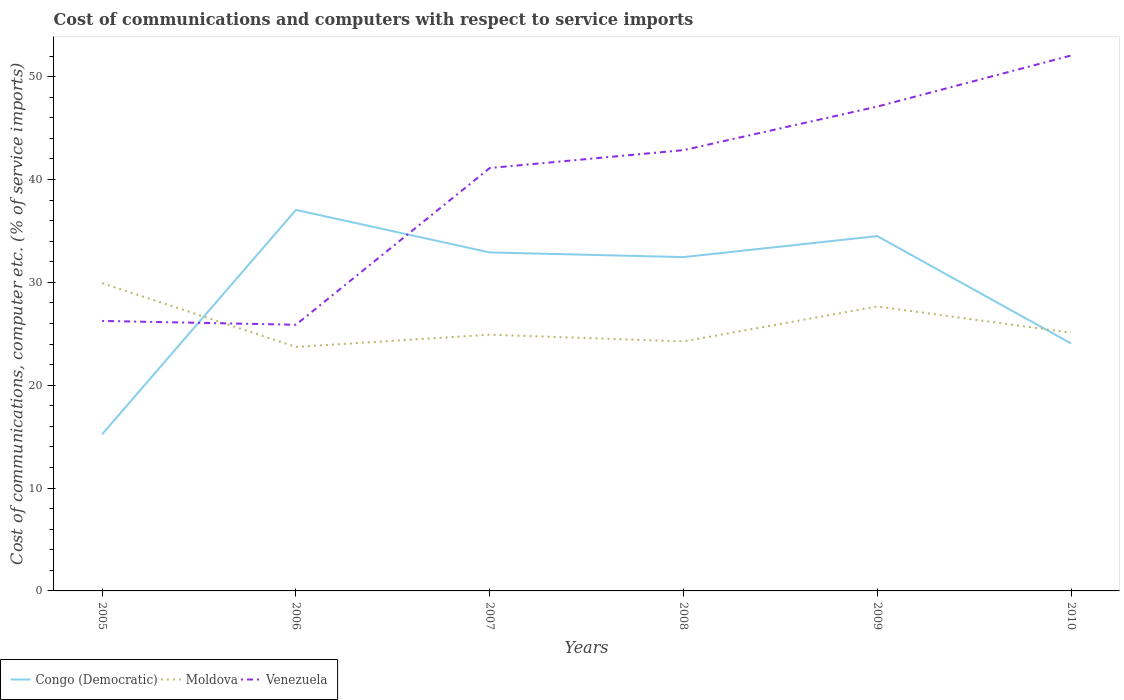Is the number of lines equal to the number of legend labels?
Your answer should be very brief. Yes. Across all years, what is the maximum cost of communications and computers in Moldova?
Make the answer very short. 23.72. What is the total cost of communications and computers in Congo (Democratic) in the graph?
Make the answer very short. 8.4. What is the difference between the highest and the second highest cost of communications and computers in Venezuela?
Offer a terse response. 26.18. What is the difference between the highest and the lowest cost of communications and computers in Congo (Democratic)?
Ensure brevity in your answer.  4. Is the cost of communications and computers in Moldova strictly greater than the cost of communications and computers in Congo (Democratic) over the years?
Make the answer very short. No. How many lines are there?
Your answer should be compact. 3. Are the values on the major ticks of Y-axis written in scientific E-notation?
Provide a succinct answer. No. What is the title of the graph?
Offer a terse response. Cost of communications and computers with respect to service imports. Does "Belize" appear as one of the legend labels in the graph?
Your answer should be very brief. No. What is the label or title of the X-axis?
Provide a short and direct response. Years. What is the label or title of the Y-axis?
Offer a very short reply. Cost of communications, computer etc. (% of service imports). What is the Cost of communications, computer etc. (% of service imports) of Congo (Democratic) in 2005?
Offer a terse response. 15.23. What is the Cost of communications, computer etc. (% of service imports) of Moldova in 2005?
Give a very brief answer. 29.92. What is the Cost of communications, computer etc. (% of service imports) in Venezuela in 2005?
Offer a terse response. 26.25. What is the Cost of communications, computer etc. (% of service imports) in Congo (Democratic) in 2006?
Provide a short and direct response. 37.04. What is the Cost of communications, computer etc. (% of service imports) in Moldova in 2006?
Keep it short and to the point. 23.72. What is the Cost of communications, computer etc. (% of service imports) in Venezuela in 2006?
Your answer should be very brief. 25.88. What is the Cost of communications, computer etc. (% of service imports) of Congo (Democratic) in 2007?
Your answer should be compact. 32.91. What is the Cost of communications, computer etc. (% of service imports) in Moldova in 2007?
Offer a terse response. 24.91. What is the Cost of communications, computer etc. (% of service imports) in Venezuela in 2007?
Your answer should be compact. 41.11. What is the Cost of communications, computer etc. (% of service imports) in Congo (Democratic) in 2008?
Keep it short and to the point. 32.45. What is the Cost of communications, computer etc. (% of service imports) of Moldova in 2008?
Provide a short and direct response. 24.26. What is the Cost of communications, computer etc. (% of service imports) in Venezuela in 2008?
Make the answer very short. 42.85. What is the Cost of communications, computer etc. (% of service imports) in Congo (Democratic) in 2009?
Provide a short and direct response. 34.49. What is the Cost of communications, computer etc. (% of service imports) in Moldova in 2009?
Ensure brevity in your answer.  27.65. What is the Cost of communications, computer etc. (% of service imports) of Venezuela in 2009?
Offer a very short reply. 47.09. What is the Cost of communications, computer etc. (% of service imports) in Congo (Democratic) in 2010?
Offer a terse response. 24.06. What is the Cost of communications, computer etc. (% of service imports) in Moldova in 2010?
Provide a succinct answer. 25.1. What is the Cost of communications, computer etc. (% of service imports) of Venezuela in 2010?
Your response must be concise. 52.05. Across all years, what is the maximum Cost of communications, computer etc. (% of service imports) of Congo (Democratic)?
Ensure brevity in your answer.  37.04. Across all years, what is the maximum Cost of communications, computer etc. (% of service imports) in Moldova?
Give a very brief answer. 29.92. Across all years, what is the maximum Cost of communications, computer etc. (% of service imports) of Venezuela?
Provide a succinct answer. 52.05. Across all years, what is the minimum Cost of communications, computer etc. (% of service imports) of Congo (Democratic)?
Make the answer very short. 15.23. Across all years, what is the minimum Cost of communications, computer etc. (% of service imports) of Moldova?
Give a very brief answer. 23.72. Across all years, what is the minimum Cost of communications, computer etc. (% of service imports) of Venezuela?
Make the answer very short. 25.88. What is the total Cost of communications, computer etc. (% of service imports) of Congo (Democratic) in the graph?
Offer a terse response. 176.19. What is the total Cost of communications, computer etc. (% of service imports) of Moldova in the graph?
Give a very brief answer. 155.56. What is the total Cost of communications, computer etc. (% of service imports) of Venezuela in the graph?
Offer a very short reply. 235.23. What is the difference between the Cost of communications, computer etc. (% of service imports) of Congo (Democratic) in 2005 and that in 2006?
Your response must be concise. -21.81. What is the difference between the Cost of communications, computer etc. (% of service imports) in Moldova in 2005 and that in 2006?
Keep it short and to the point. 6.2. What is the difference between the Cost of communications, computer etc. (% of service imports) in Venezuela in 2005 and that in 2006?
Provide a succinct answer. 0.37. What is the difference between the Cost of communications, computer etc. (% of service imports) in Congo (Democratic) in 2005 and that in 2007?
Your answer should be very brief. -17.67. What is the difference between the Cost of communications, computer etc. (% of service imports) in Moldova in 2005 and that in 2007?
Your response must be concise. 5.01. What is the difference between the Cost of communications, computer etc. (% of service imports) in Venezuela in 2005 and that in 2007?
Offer a very short reply. -14.86. What is the difference between the Cost of communications, computer etc. (% of service imports) in Congo (Democratic) in 2005 and that in 2008?
Keep it short and to the point. -17.22. What is the difference between the Cost of communications, computer etc. (% of service imports) of Moldova in 2005 and that in 2008?
Provide a short and direct response. 5.66. What is the difference between the Cost of communications, computer etc. (% of service imports) of Venezuela in 2005 and that in 2008?
Your answer should be very brief. -16.6. What is the difference between the Cost of communications, computer etc. (% of service imports) of Congo (Democratic) in 2005 and that in 2009?
Provide a succinct answer. -19.26. What is the difference between the Cost of communications, computer etc. (% of service imports) of Moldova in 2005 and that in 2009?
Your response must be concise. 2.27. What is the difference between the Cost of communications, computer etc. (% of service imports) of Venezuela in 2005 and that in 2009?
Provide a succinct answer. -20.84. What is the difference between the Cost of communications, computer etc. (% of service imports) of Congo (Democratic) in 2005 and that in 2010?
Ensure brevity in your answer.  -8.83. What is the difference between the Cost of communications, computer etc. (% of service imports) of Moldova in 2005 and that in 2010?
Your response must be concise. 4.82. What is the difference between the Cost of communications, computer etc. (% of service imports) of Venezuela in 2005 and that in 2010?
Your answer should be compact. -25.8. What is the difference between the Cost of communications, computer etc. (% of service imports) in Congo (Democratic) in 2006 and that in 2007?
Provide a short and direct response. 4.13. What is the difference between the Cost of communications, computer etc. (% of service imports) of Moldova in 2006 and that in 2007?
Ensure brevity in your answer.  -1.19. What is the difference between the Cost of communications, computer etc. (% of service imports) in Venezuela in 2006 and that in 2007?
Your answer should be very brief. -15.24. What is the difference between the Cost of communications, computer etc. (% of service imports) in Congo (Democratic) in 2006 and that in 2008?
Your answer should be very brief. 4.59. What is the difference between the Cost of communications, computer etc. (% of service imports) in Moldova in 2006 and that in 2008?
Keep it short and to the point. -0.54. What is the difference between the Cost of communications, computer etc. (% of service imports) of Venezuela in 2006 and that in 2008?
Keep it short and to the point. -16.98. What is the difference between the Cost of communications, computer etc. (% of service imports) in Congo (Democratic) in 2006 and that in 2009?
Your answer should be very brief. 2.54. What is the difference between the Cost of communications, computer etc. (% of service imports) of Moldova in 2006 and that in 2009?
Give a very brief answer. -3.93. What is the difference between the Cost of communications, computer etc. (% of service imports) of Venezuela in 2006 and that in 2009?
Ensure brevity in your answer.  -21.21. What is the difference between the Cost of communications, computer etc. (% of service imports) in Congo (Democratic) in 2006 and that in 2010?
Give a very brief answer. 12.98. What is the difference between the Cost of communications, computer etc. (% of service imports) in Moldova in 2006 and that in 2010?
Offer a very short reply. -1.38. What is the difference between the Cost of communications, computer etc. (% of service imports) of Venezuela in 2006 and that in 2010?
Provide a succinct answer. -26.18. What is the difference between the Cost of communications, computer etc. (% of service imports) of Congo (Democratic) in 2007 and that in 2008?
Your answer should be compact. 0.45. What is the difference between the Cost of communications, computer etc. (% of service imports) in Moldova in 2007 and that in 2008?
Make the answer very short. 0.65. What is the difference between the Cost of communications, computer etc. (% of service imports) in Venezuela in 2007 and that in 2008?
Provide a succinct answer. -1.74. What is the difference between the Cost of communications, computer etc. (% of service imports) of Congo (Democratic) in 2007 and that in 2009?
Offer a very short reply. -1.59. What is the difference between the Cost of communications, computer etc. (% of service imports) of Moldova in 2007 and that in 2009?
Offer a terse response. -2.74. What is the difference between the Cost of communications, computer etc. (% of service imports) in Venezuela in 2007 and that in 2009?
Your answer should be compact. -5.97. What is the difference between the Cost of communications, computer etc. (% of service imports) in Congo (Democratic) in 2007 and that in 2010?
Provide a succinct answer. 8.85. What is the difference between the Cost of communications, computer etc. (% of service imports) of Moldova in 2007 and that in 2010?
Make the answer very short. -0.19. What is the difference between the Cost of communications, computer etc. (% of service imports) in Venezuela in 2007 and that in 2010?
Keep it short and to the point. -10.94. What is the difference between the Cost of communications, computer etc. (% of service imports) in Congo (Democratic) in 2008 and that in 2009?
Your response must be concise. -2.04. What is the difference between the Cost of communications, computer etc. (% of service imports) in Moldova in 2008 and that in 2009?
Ensure brevity in your answer.  -3.4. What is the difference between the Cost of communications, computer etc. (% of service imports) in Venezuela in 2008 and that in 2009?
Provide a succinct answer. -4.23. What is the difference between the Cost of communications, computer etc. (% of service imports) of Congo (Democratic) in 2008 and that in 2010?
Ensure brevity in your answer.  8.4. What is the difference between the Cost of communications, computer etc. (% of service imports) of Moldova in 2008 and that in 2010?
Provide a short and direct response. -0.84. What is the difference between the Cost of communications, computer etc. (% of service imports) in Venezuela in 2008 and that in 2010?
Your answer should be very brief. -9.2. What is the difference between the Cost of communications, computer etc. (% of service imports) in Congo (Democratic) in 2009 and that in 2010?
Give a very brief answer. 10.44. What is the difference between the Cost of communications, computer etc. (% of service imports) in Moldova in 2009 and that in 2010?
Provide a short and direct response. 2.55. What is the difference between the Cost of communications, computer etc. (% of service imports) in Venezuela in 2009 and that in 2010?
Offer a terse response. -4.96. What is the difference between the Cost of communications, computer etc. (% of service imports) of Congo (Democratic) in 2005 and the Cost of communications, computer etc. (% of service imports) of Moldova in 2006?
Your answer should be compact. -8.49. What is the difference between the Cost of communications, computer etc. (% of service imports) of Congo (Democratic) in 2005 and the Cost of communications, computer etc. (% of service imports) of Venezuela in 2006?
Your answer should be compact. -10.64. What is the difference between the Cost of communications, computer etc. (% of service imports) of Moldova in 2005 and the Cost of communications, computer etc. (% of service imports) of Venezuela in 2006?
Provide a succinct answer. 4.04. What is the difference between the Cost of communications, computer etc. (% of service imports) in Congo (Democratic) in 2005 and the Cost of communications, computer etc. (% of service imports) in Moldova in 2007?
Your response must be concise. -9.68. What is the difference between the Cost of communications, computer etc. (% of service imports) in Congo (Democratic) in 2005 and the Cost of communications, computer etc. (% of service imports) in Venezuela in 2007?
Your answer should be very brief. -25.88. What is the difference between the Cost of communications, computer etc. (% of service imports) of Moldova in 2005 and the Cost of communications, computer etc. (% of service imports) of Venezuela in 2007?
Offer a terse response. -11.19. What is the difference between the Cost of communications, computer etc. (% of service imports) in Congo (Democratic) in 2005 and the Cost of communications, computer etc. (% of service imports) in Moldova in 2008?
Your response must be concise. -9.02. What is the difference between the Cost of communications, computer etc. (% of service imports) in Congo (Democratic) in 2005 and the Cost of communications, computer etc. (% of service imports) in Venezuela in 2008?
Offer a terse response. -27.62. What is the difference between the Cost of communications, computer etc. (% of service imports) of Moldova in 2005 and the Cost of communications, computer etc. (% of service imports) of Venezuela in 2008?
Your answer should be very brief. -12.93. What is the difference between the Cost of communications, computer etc. (% of service imports) in Congo (Democratic) in 2005 and the Cost of communications, computer etc. (% of service imports) in Moldova in 2009?
Offer a terse response. -12.42. What is the difference between the Cost of communications, computer etc. (% of service imports) of Congo (Democratic) in 2005 and the Cost of communications, computer etc. (% of service imports) of Venezuela in 2009?
Your answer should be compact. -31.85. What is the difference between the Cost of communications, computer etc. (% of service imports) of Moldova in 2005 and the Cost of communications, computer etc. (% of service imports) of Venezuela in 2009?
Make the answer very short. -17.17. What is the difference between the Cost of communications, computer etc. (% of service imports) in Congo (Democratic) in 2005 and the Cost of communications, computer etc. (% of service imports) in Moldova in 2010?
Give a very brief answer. -9.87. What is the difference between the Cost of communications, computer etc. (% of service imports) in Congo (Democratic) in 2005 and the Cost of communications, computer etc. (% of service imports) in Venezuela in 2010?
Provide a short and direct response. -36.82. What is the difference between the Cost of communications, computer etc. (% of service imports) of Moldova in 2005 and the Cost of communications, computer etc. (% of service imports) of Venezuela in 2010?
Give a very brief answer. -22.13. What is the difference between the Cost of communications, computer etc. (% of service imports) of Congo (Democratic) in 2006 and the Cost of communications, computer etc. (% of service imports) of Moldova in 2007?
Make the answer very short. 12.13. What is the difference between the Cost of communications, computer etc. (% of service imports) of Congo (Democratic) in 2006 and the Cost of communications, computer etc. (% of service imports) of Venezuela in 2007?
Your response must be concise. -4.07. What is the difference between the Cost of communications, computer etc. (% of service imports) of Moldova in 2006 and the Cost of communications, computer etc. (% of service imports) of Venezuela in 2007?
Offer a very short reply. -17.39. What is the difference between the Cost of communications, computer etc. (% of service imports) in Congo (Democratic) in 2006 and the Cost of communications, computer etc. (% of service imports) in Moldova in 2008?
Your answer should be compact. 12.78. What is the difference between the Cost of communications, computer etc. (% of service imports) in Congo (Democratic) in 2006 and the Cost of communications, computer etc. (% of service imports) in Venezuela in 2008?
Provide a short and direct response. -5.81. What is the difference between the Cost of communications, computer etc. (% of service imports) in Moldova in 2006 and the Cost of communications, computer etc. (% of service imports) in Venezuela in 2008?
Your answer should be compact. -19.13. What is the difference between the Cost of communications, computer etc. (% of service imports) in Congo (Democratic) in 2006 and the Cost of communications, computer etc. (% of service imports) in Moldova in 2009?
Provide a succinct answer. 9.39. What is the difference between the Cost of communications, computer etc. (% of service imports) of Congo (Democratic) in 2006 and the Cost of communications, computer etc. (% of service imports) of Venezuela in 2009?
Offer a very short reply. -10.05. What is the difference between the Cost of communications, computer etc. (% of service imports) in Moldova in 2006 and the Cost of communications, computer etc. (% of service imports) in Venezuela in 2009?
Keep it short and to the point. -23.37. What is the difference between the Cost of communications, computer etc. (% of service imports) of Congo (Democratic) in 2006 and the Cost of communications, computer etc. (% of service imports) of Moldova in 2010?
Your answer should be very brief. 11.94. What is the difference between the Cost of communications, computer etc. (% of service imports) in Congo (Democratic) in 2006 and the Cost of communications, computer etc. (% of service imports) in Venezuela in 2010?
Your response must be concise. -15.01. What is the difference between the Cost of communications, computer etc. (% of service imports) in Moldova in 2006 and the Cost of communications, computer etc. (% of service imports) in Venezuela in 2010?
Ensure brevity in your answer.  -28.33. What is the difference between the Cost of communications, computer etc. (% of service imports) of Congo (Democratic) in 2007 and the Cost of communications, computer etc. (% of service imports) of Moldova in 2008?
Your answer should be very brief. 8.65. What is the difference between the Cost of communications, computer etc. (% of service imports) in Congo (Democratic) in 2007 and the Cost of communications, computer etc. (% of service imports) in Venezuela in 2008?
Your answer should be compact. -9.95. What is the difference between the Cost of communications, computer etc. (% of service imports) in Moldova in 2007 and the Cost of communications, computer etc. (% of service imports) in Venezuela in 2008?
Keep it short and to the point. -17.94. What is the difference between the Cost of communications, computer etc. (% of service imports) in Congo (Democratic) in 2007 and the Cost of communications, computer etc. (% of service imports) in Moldova in 2009?
Ensure brevity in your answer.  5.25. What is the difference between the Cost of communications, computer etc. (% of service imports) of Congo (Democratic) in 2007 and the Cost of communications, computer etc. (% of service imports) of Venezuela in 2009?
Keep it short and to the point. -14.18. What is the difference between the Cost of communications, computer etc. (% of service imports) of Moldova in 2007 and the Cost of communications, computer etc. (% of service imports) of Venezuela in 2009?
Provide a short and direct response. -22.18. What is the difference between the Cost of communications, computer etc. (% of service imports) of Congo (Democratic) in 2007 and the Cost of communications, computer etc. (% of service imports) of Moldova in 2010?
Give a very brief answer. 7.8. What is the difference between the Cost of communications, computer etc. (% of service imports) of Congo (Democratic) in 2007 and the Cost of communications, computer etc. (% of service imports) of Venezuela in 2010?
Your response must be concise. -19.14. What is the difference between the Cost of communications, computer etc. (% of service imports) of Moldova in 2007 and the Cost of communications, computer etc. (% of service imports) of Venezuela in 2010?
Give a very brief answer. -27.14. What is the difference between the Cost of communications, computer etc. (% of service imports) of Congo (Democratic) in 2008 and the Cost of communications, computer etc. (% of service imports) of Moldova in 2009?
Your response must be concise. 4.8. What is the difference between the Cost of communications, computer etc. (% of service imports) in Congo (Democratic) in 2008 and the Cost of communications, computer etc. (% of service imports) in Venezuela in 2009?
Provide a succinct answer. -14.63. What is the difference between the Cost of communications, computer etc. (% of service imports) of Moldova in 2008 and the Cost of communications, computer etc. (% of service imports) of Venezuela in 2009?
Your answer should be compact. -22.83. What is the difference between the Cost of communications, computer etc. (% of service imports) in Congo (Democratic) in 2008 and the Cost of communications, computer etc. (% of service imports) in Moldova in 2010?
Keep it short and to the point. 7.35. What is the difference between the Cost of communications, computer etc. (% of service imports) of Congo (Democratic) in 2008 and the Cost of communications, computer etc. (% of service imports) of Venezuela in 2010?
Offer a very short reply. -19.6. What is the difference between the Cost of communications, computer etc. (% of service imports) of Moldova in 2008 and the Cost of communications, computer etc. (% of service imports) of Venezuela in 2010?
Make the answer very short. -27.79. What is the difference between the Cost of communications, computer etc. (% of service imports) in Congo (Democratic) in 2009 and the Cost of communications, computer etc. (% of service imports) in Moldova in 2010?
Make the answer very short. 9.39. What is the difference between the Cost of communications, computer etc. (% of service imports) of Congo (Democratic) in 2009 and the Cost of communications, computer etc. (% of service imports) of Venezuela in 2010?
Ensure brevity in your answer.  -17.56. What is the difference between the Cost of communications, computer etc. (% of service imports) in Moldova in 2009 and the Cost of communications, computer etc. (% of service imports) in Venezuela in 2010?
Keep it short and to the point. -24.4. What is the average Cost of communications, computer etc. (% of service imports) in Congo (Democratic) per year?
Provide a succinct answer. 29.36. What is the average Cost of communications, computer etc. (% of service imports) in Moldova per year?
Ensure brevity in your answer.  25.93. What is the average Cost of communications, computer etc. (% of service imports) in Venezuela per year?
Provide a short and direct response. 39.2. In the year 2005, what is the difference between the Cost of communications, computer etc. (% of service imports) in Congo (Democratic) and Cost of communications, computer etc. (% of service imports) in Moldova?
Offer a very short reply. -14.69. In the year 2005, what is the difference between the Cost of communications, computer etc. (% of service imports) of Congo (Democratic) and Cost of communications, computer etc. (% of service imports) of Venezuela?
Ensure brevity in your answer.  -11.02. In the year 2005, what is the difference between the Cost of communications, computer etc. (% of service imports) of Moldova and Cost of communications, computer etc. (% of service imports) of Venezuela?
Offer a very short reply. 3.67. In the year 2006, what is the difference between the Cost of communications, computer etc. (% of service imports) of Congo (Democratic) and Cost of communications, computer etc. (% of service imports) of Moldova?
Your answer should be compact. 13.32. In the year 2006, what is the difference between the Cost of communications, computer etc. (% of service imports) of Congo (Democratic) and Cost of communications, computer etc. (% of service imports) of Venezuela?
Give a very brief answer. 11.16. In the year 2006, what is the difference between the Cost of communications, computer etc. (% of service imports) of Moldova and Cost of communications, computer etc. (% of service imports) of Venezuela?
Your answer should be very brief. -2.16. In the year 2007, what is the difference between the Cost of communications, computer etc. (% of service imports) of Congo (Democratic) and Cost of communications, computer etc. (% of service imports) of Moldova?
Offer a terse response. 8. In the year 2007, what is the difference between the Cost of communications, computer etc. (% of service imports) of Congo (Democratic) and Cost of communications, computer etc. (% of service imports) of Venezuela?
Give a very brief answer. -8.21. In the year 2007, what is the difference between the Cost of communications, computer etc. (% of service imports) of Moldova and Cost of communications, computer etc. (% of service imports) of Venezuela?
Give a very brief answer. -16.2. In the year 2008, what is the difference between the Cost of communications, computer etc. (% of service imports) in Congo (Democratic) and Cost of communications, computer etc. (% of service imports) in Moldova?
Offer a terse response. 8.2. In the year 2008, what is the difference between the Cost of communications, computer etc. (% of service imports) in Congo (Democratic) and Cost of communications, computer etc. (% of service imports) in Venezuela?
Make the answer very short. -10.4. In the year 2008, what is the difference between the Cost of communications, computer etc. (% of service imports) of Moldova and Cost of communications, computer etc. (% of service imports) of Venezuela?
Give a very brief answer. -18.6. In the year 2009, what is the difference between the Cost of communications, computer etc. (% of service imports) of Congo (Democratic) and Cost of communications, computer etc. (% of service imports) of Moldova?
Provide a succinct answer. 6.84. In the year 2009, what is the difference between the Cost of communications, computer etc. (% of service imports) of Congo (Democratic) and Cost of communications, computer etc. (% of service imports) of Venezuela?
Ensure brevity in your answer.  -12.59. In the year 2009, what is the difference between the Cost of communications, computer etc. (% of service imports) in Moldova and Cost of communications, computer etc. (% of service imports) in Venezuela?
Your response must be concise. -19.43. In the year 2010, what is the difference between the Cost of communications, computer etc. (% of service imports) of Congo (Democratic) and Cost of communications, computer etc. (% of service imports) of Moldova?
Ensure brevity in your answer.  -1.04. In the year 2010, what is the difference between the Cost of communications, computer etc. (% of service imports) of Congo (Democratic) and Cost of communications, computer etc. (% of service imports) of Venezuela?
Your answer should be compact. -27.99. In the year 2010, what is the difference between the Cost of communications, computer etc. (% of service imports) of Moldova and Cost of communications, computer etc. (% of service imports) of Venezuela?
Make the answer very short. -26.95. What is the ratio of the Cost of communications, computer etc. (% of service imports) in Congo (Democratic) in 2005 to that in 2006?
Provide a short and direct response. 0.41. What is the ratio of the Cost of communications, computer etc. (% of service imports) of Moldova in 2005 to that in 2006?
Offer a terse response. 1.26. What is the ratio of the Cost of communications, computer etc. (% of service imports) in Venezuela in 2005 to that in 2006?
Provide a short and direct response. 1.01. What is the ratio of the Cost of communications, computer etc. (% of service imports) in Congo (Democratic) in 2005 to that in 2007?
Ensure brevity in your answer.  0.46. What is the ratio of the Cost of communications, computer etc. (% of service imports) in Moldova in 2005 to that in 2007?
Provide a succinct answer. 1.2. What is the ratio of the Cost of communications, computer etc. (% of service imports) in Venezuela in 2005 to that in 2007?
Offer a very short reply. 0.64. What is the ratio of the Cost of communications, computer etc. (% of service imports) in Congo (Democratic) in 2005 to that in 2008?
Provide a succinct answer. 0.47. What is the ratio of the Cost of communications, computer etc. (% of service imports) of Moldova in 2005 to that in 2008?
Your response must be concise. 1.23. What is the ratio of the Cost of communications, computer etc. (% of service imports) in Venezuela in 2005 to that in 2008?
Keep it short and to the point. 0.61. What is the ratio of the Cost of communications, computer etc. (% of service imports) in Congo (Democratic) in 2005 to that in 2009?
Ensure brevity in your answer.  0.44. What is the ratio of the Cost of communications, computer etc. (% of service imports) of Moldova in 2005 to that in 2009?
Keep it short and to the point. 1.08. What is the ratio of the Cost of communications, computer etc. (% of service imports) of Venezuela in 2005 to that in 2009?
Offer a terse response. 0.56. What is the ratio of the Cost of communications, computer etc. (% of service imports) in Congo (Democratic) in 2005 to that in 2010?
Offer a very short reply. 0.63. What is the ratio of the Cost of communications, computer etc. (% of service imports) of Moldova in 2005 to that in 2010?
Provide a succinct answer. 1.19. What is the ratio of the Cost of communications, computer etc. (% of service imports) in Venezuela in 2005 to that in 2010?
Your answer should be compact. 0.5. What is the ratio of the Cost of communications, computer etc. (% of service imports) in Congo (Democratic) in 2006 to that in 2007?
Your response must be concise. 1.13. What is the ratio of the Cost of communications, computer etc. (% of service imports) of Moldova in 2006 to that in 2007?
Offer a terse response. 0.95. What is the ratio of the Cost of communications, computer etc. (% of service imports) in Venezuela in 2006 to that in 2007?
Offer a terse response. 0.63. What is the ratio of the Cost of communications, computer etc. (% of service imports) in Congo (Democratic) in 2006 to that in 2008?
Keep it short and to the point. 1.14. What is the ratio of the Cost of communications, computer etc. (% of service imports) in Moldova in 2006 to that in 2008?
Ensure brevity in your answer.  0.98. What is the ratio of the Cost of communications, computer etc. (% of service imports) in Venezuela in 2006 to that in 2008?
Ensure brevity in your answer.  0.6. What is the ratio of the Cost of communications, computer etc. (% of service imports) in Congo (Democratic) in 2006 to that in 2009?
Your response must be concise. 1.07. What is the ratio of the Cost of communications, computer etc. (% of service imports) in Moldova in 2006 to that in 2009?
Ensure brevity in your answer.  0.86. What is the ratio of the Cost of communications, computer etc. (% of service imports) in Venezuela in 2006 to that in 2009?
Provide a short and direct response. 0.55. What is the ratio of the Cost of communications, computer etc. (% of service imports) of Congo (Democratic) in 2006 to that in 2010?
Give a very brief answer. 1.54. What is the ratio of the Cost of communications, computer etc. (% of service imports) in Moldova in 2006 to that in 2010?
Give a very brief answer. 0.94. What is the ratio of the Cost of communications, computer etc. (% of service imports) in Venezuela in 2006 to that in 2010?
Make the answer very short. 0.5. What is the ratio of the Cost of communications, computer etc. (% of service imports) of Congo (Democratic) in 2007 to that in 2008?
Your response must be concise. 1.01. What is the ratio of the Cost of communications, computer etc. (% of service imports) of Moldova in 2007 to that in 2008?
Offer a very short reply. 1.03. What is the ratio of the Cost of communications, computer etc. (% of service imports) in Venezuela in 2007 to that in 2008?
Give a very brief answer. 0.96. What is the ratio of the Cost of communications, computer etc. (% of service imports) in Congo (Democratic) in 2007 to that in 2009?
Offer a terse response. 0.95. What is the ratio of the Cost of communications, computer etc. (% of service imports) in Moldova in 2007 to that in 2009?
Your answer should be very brief. 0.9. What is the ratio of the Cost of communications, computer etc. (% of service imports) in Venezuela in 2007 to that in 2009?
Your answer should be compact. 0.87. What is the ratio of the Cost of communications, computer etc. (% of service imports) of Congo (Democratic) in 2007 to that in 2010?
Make the answer very short. 1.37. What is the ratio of the Cost of communications, computer etc. (% of service imports) in Moldova in 2007 to that in 2010?
Ensure brevity in your answer.  0.99. What is the ratio of the Cost of communications, computer etc. (% of service imports) of Venezuela in 2007 to that in 2010?
Provide a succinct answer. 0.79. What is the ratio of the Cost of communications, computer etc. (% of service imports) of Congo (Democratic) in 2008 to that in 2009?
Your answer should be very brief. 0.94. What is the ratio of the Cost of communications, computer etc. (% of service imports) of Moldova in 2008 to that in 2009?
Your response must be concise. 0.88. What is the ratio of the Cost of communications, computer etc. (% of service imports) in Venezuela in 2008 to that in 2009?
Give a very brief answer. 0.91. What is the ratio of the Cost of communications, computer etc. (% of service imports) of Congo (Democratic) in 2008 to that in 2010?
Provide a short and direct response. 1.35. What is the ratio of the Cost of communications, computer etc. (% of service imports) in Moldova in 2008 to that in 2010?
Your response must be concise. 0.97. What is the ratio of the Cost of communications, computer etc. (% of service imports) of Venezuela in 2008 to that in 2010?
Provide a succinct answer. 0.82. What is the ratio of the Cost of communications, computer etc. (% of service imports) in Congo (Democratic) in 2009 to that in 2010?
Give a very brief answer. 1.43. What is the ratio of the Cost of communications, computer etc. (% of service imports) of Moldova in 2009 to that in 2010?
Ensure brevity in your answer.  1.1. What is the ratio of the Cost of communications, computer etc. (% of service imports) of Venezuela in 2009 to that in 2010?
Your answer should be compact. 0.9. What is the difference between the highest and the second highest Cost of communications, computer etc. (% of service imports) of Congo (Democratic)?
Offer a terse response. 2.54. What is the difference between the highest and the second highest Cost of communications, computer etc. (% of service imports) of Moldova?
Give a very brief answer. 2.27. What is the difference between the highest and the second highest Cost of communications, computer etc. (% of service imports) in Venezuela?
Give a very brief answer. 4.96. What is the difference between the highest and the lowest Cost of communications, computer etc. (% of service imports) in Congo (Democratic)?
Keep it short and to the point. 21.81. What is the difference between the highest and the lowest Cost of communications, computer etc. (% of service imports) of Moldova?
Ensure brevity in your answer.  6.2. What is the difference between the highest and the lowest Cost of communications, computer etc. (% of service imports) of Venezuela?
Keep it short and to the point. 26.18. 